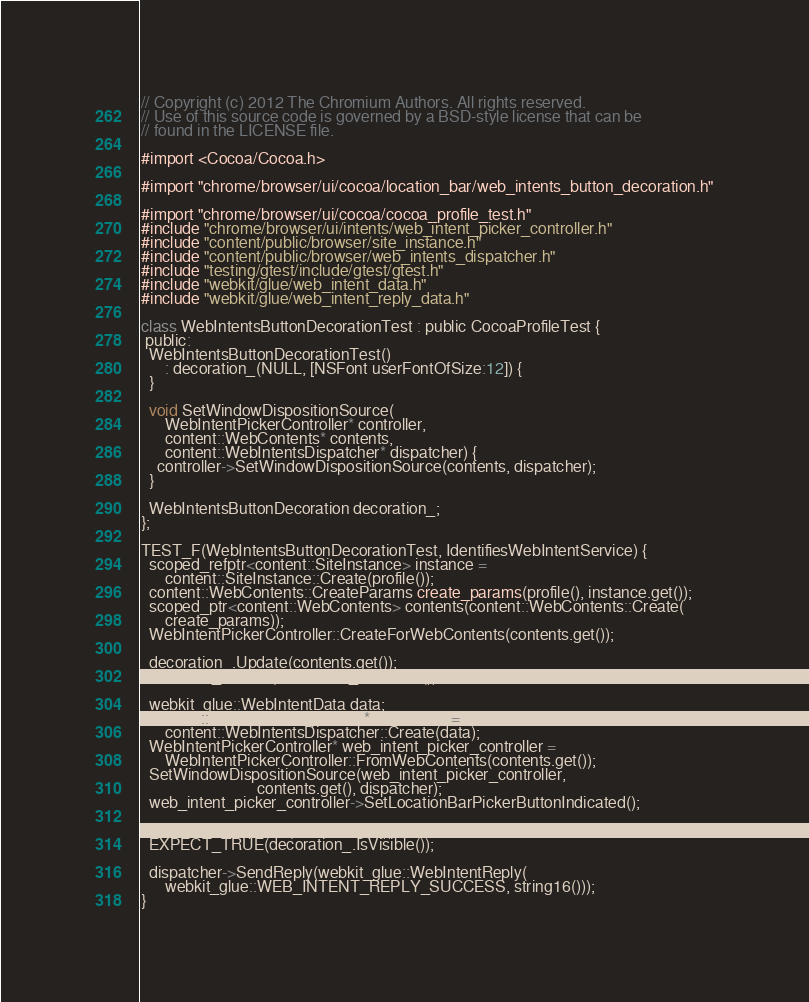<code> <loc_0><loc_0><loc_500><loc_500><_ObjectiveC_>// Copyright (c) 2012 The Chromium Authors. All rights reserved.
// Use of this source code is governed by a BSD-style license that can be
// found in the LICENSE file.

#import <Cocoa/Cocoa.h>

#import "chrome/browser/ui/cocoa/location_bar/web_intents_button_decoration.h"

#import "chrome/browser/ui/cocoa/cocoa_profile_test.h"
#include "chrome/browser/ui/intents/web_intent_picker_controller.h"
#include "content/public/browser/site_instance.h"
#include "content/public/browser/web_intents_dispatcher.h"
#include "testing/gtest/include/gtest/gtest.h"
#include "webkit/glue/web_intent_data.h"
#include "webkit/glue/web_intent_reply_data.h"

class WebIntentsButtonDecorationTest : public CocoaProfileTest {
 public:
  WebIntentsButtonDecorationTest()
      : decoration_(NULL, [NSFont userFontOfSize:12]) {
  }

  void SetWindowDispositionSource(
      WebIntentPickerController* controller,
      content::WebContents* contents,
      content::WebIntentsDispatcher* dispatcher) {
    controller->SetWindowDispositionSource(contents, dispatcher);
  }

  WebIntentsButtonDecoration decoration_;
};

TEST_F(WebIntentsButtonDecorationTest, IdentifiesWebIntentService) {
  scoped_refptr<content::SiteInstance> instance =
      content::SiteInstance::Create(profile());
  content::WebContents::CreateParams create_params(profile(), instance.get());
  scoped_ptr<content::WebContents> contents(content::WebContents::Create(
      create_params));
  WebIntentPickerController::CreateForWebContents(contents.get());

  decoration_.Update(contents.get());
  EXPECT_FALSE(decoration_.IsVisible());

  webkit_glue::WebIntentData data;
  content::WebIntentsDispatcher* dispatcher =
      content::WebIntentsDispatcher::Create(data);
  WebIntentPickerController* web_intent_picker_controller =
      WebIntentPickerController::FromWebContents(contents.get());
  SetWindowDispositionSource(web_intent_picker_controller,
                             contents.get(), dispatcher);
  web_intent_picker_controller->SetLocationBarPickerButtonIndicated();

  decoration_.Update(contents.get());
  EXPECT_TRUE(decoration_.IsVisible());

  dispatcher->SendReply(webkit_glue::WebIntentReply(
      webkit_glue::WEB_INTENT_REPLY_SUCCESS, string16()));
}
</code> 